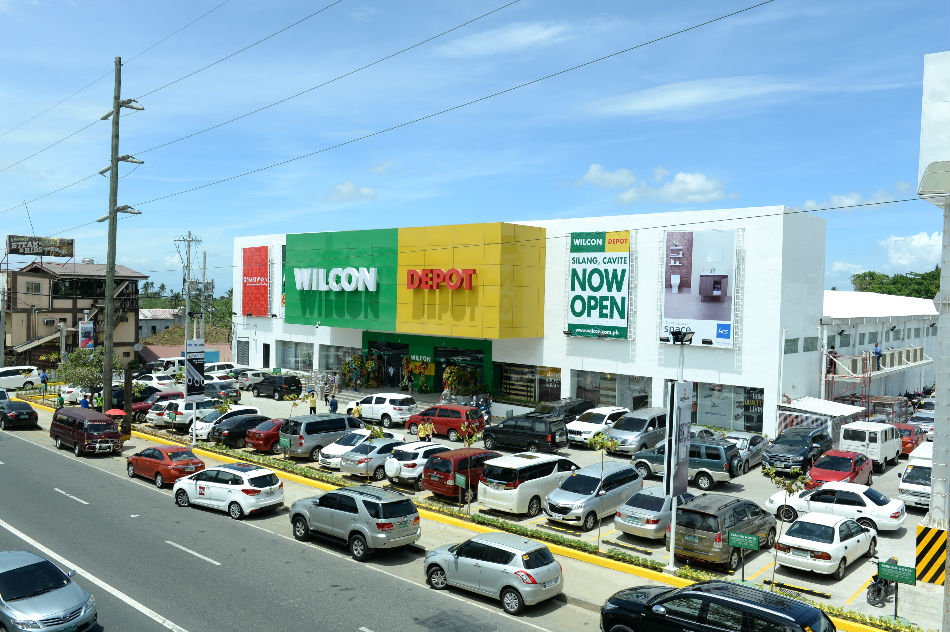Based on the visual cues, construct a realistic narrative for a day in the life of a shop owner in this establishment. As the sun rises, the shop owner, Mr. Tan, arrives early to open his home improvement store at Wilcon Depot. After a swift morning briefing with his staff, he ensures the shelves are stocked and the displays are looking their best. By mid-morning, the parking lot starts to fill with eager customers, and Mr. Tan finds himself engaging with a steady stream of shoppers. He assists customers in choosing the right materials for their home projects, offers advice, and oversees transactions at the register. During a brief afternoon lull, he restocks popular items and reviews inventory. The day continues with a mix of assisting customers and managing backend tasks until closing time, when he finally locks up, satisfied with another successful day of business. 